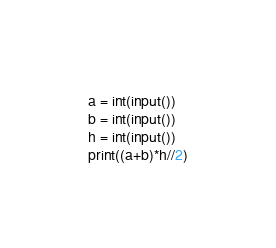<code> <loc_0><loc_0><loc_500><loc_500><_Python_>a = int(input())
b = int(input())
h = int(input())
print((a+b)*h//2)</code> 